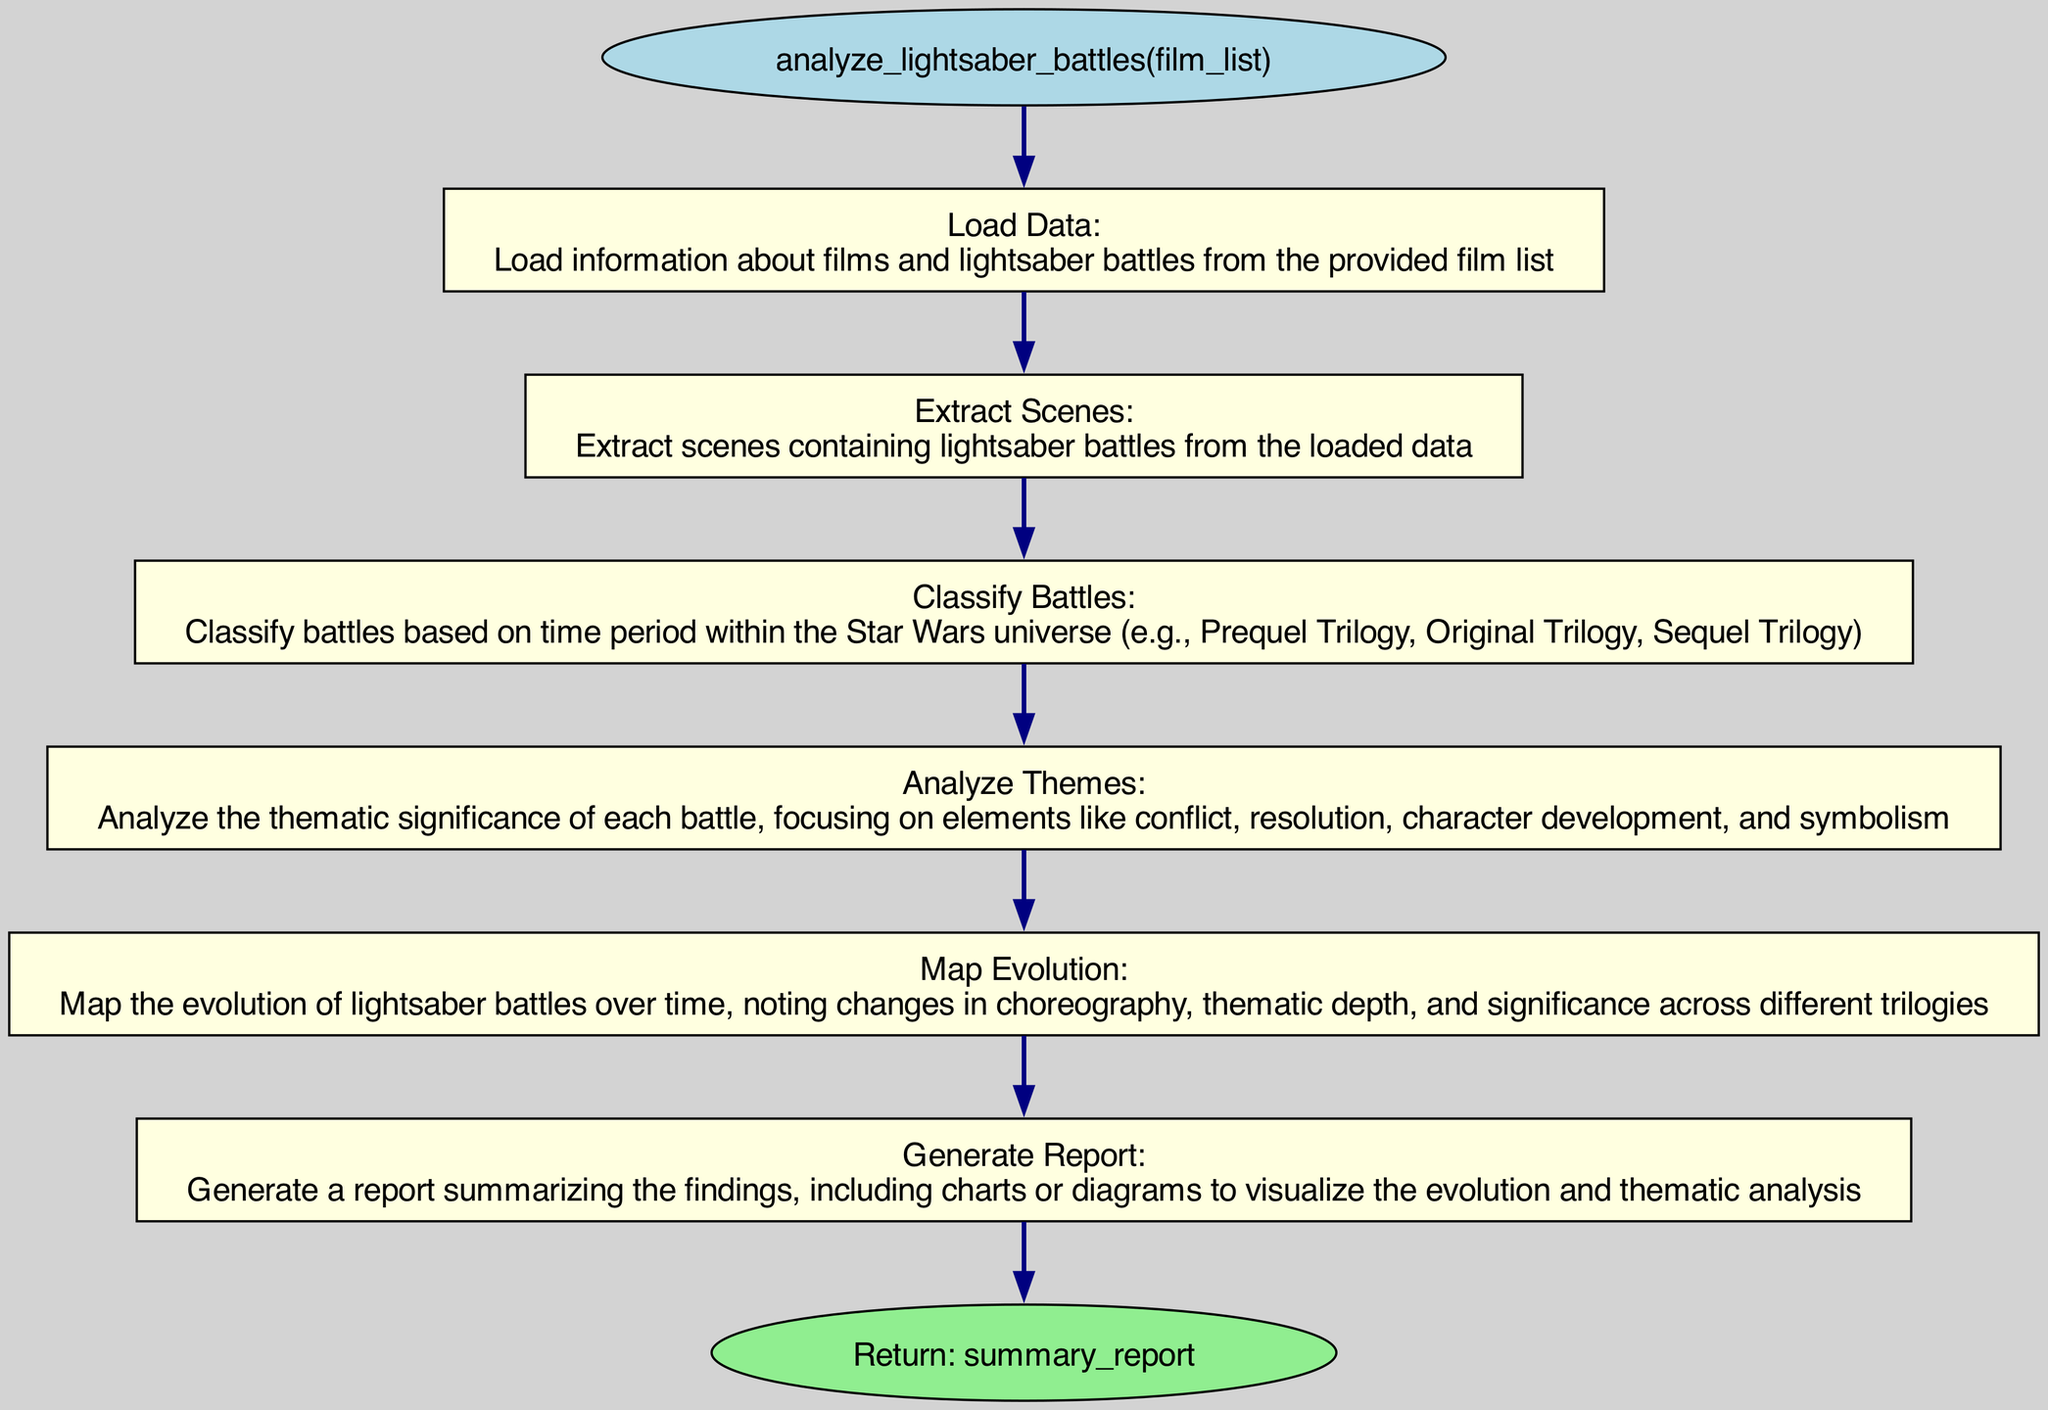What is the first step in the function? The diagram shows that the first step in the function is "Load Data," which describes loading information about films and lightsaber battles.
Answer: Load Data How many parameters does the function have? The function has one parameter, which is "film_list," as indicated in the diagram near the function name.
Answer: one What is the final step before the return? The final step before the return in the diagram is "Generate Report," which summarizes the findings.
Answer: Generate Report Which step involves thematic analysis? The step that involves thematic analysis is "Analyze Themes," which specifically focuses on the significance of battles with respect to various themes.
Answer: Analyze Themes What does the function return? The function returns "summary_report," as stated in the return node of the diagram.
Answer: summary_report In which step are the battles classified? The battles are classified in the "Classify Battles" step, which categorizes them based on their time period within the Star Wars universe.
Answer: Classify Battles How many steps are there in total? The diagram indicates that there are six steps in total, starting from loading data and ending with generating a report.
Answer: six What is the relationship between "Load Data" and "Extract Scenes"? The relationship is sequential; "Load Data" is the first step that feeds into "Extract Scenes," indicating that data must be loaded before extracting specific scenes.
Answer: sequential What theme does "Analyze Themes" focus on? "Analyze Themes" focuses on elements like conflict, resolution, character development, and symbolism, as described in that step of the diagram.
Answer: conflict, resolution, character development, symbolism 